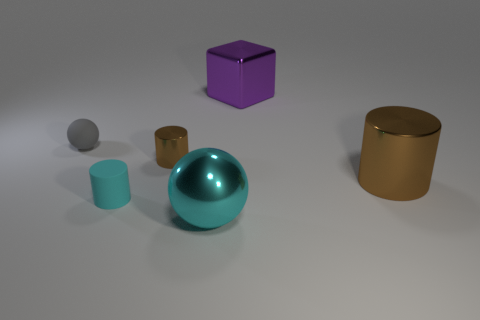Add 3 large cyan shiny spheres. How many objects exist? 9 Subtract all cubes. How many objects are left? 5 Subtract all purple things. Subtract all cyan balls. How many objects are left? 4 Add 2 gray spheres. How many gray spheres are left? 3 Add 6 tiny rubber spheres. How many tiny rubber spheres exist? 7 Subtract 0 cyan blocks. How many objects are left? 6 